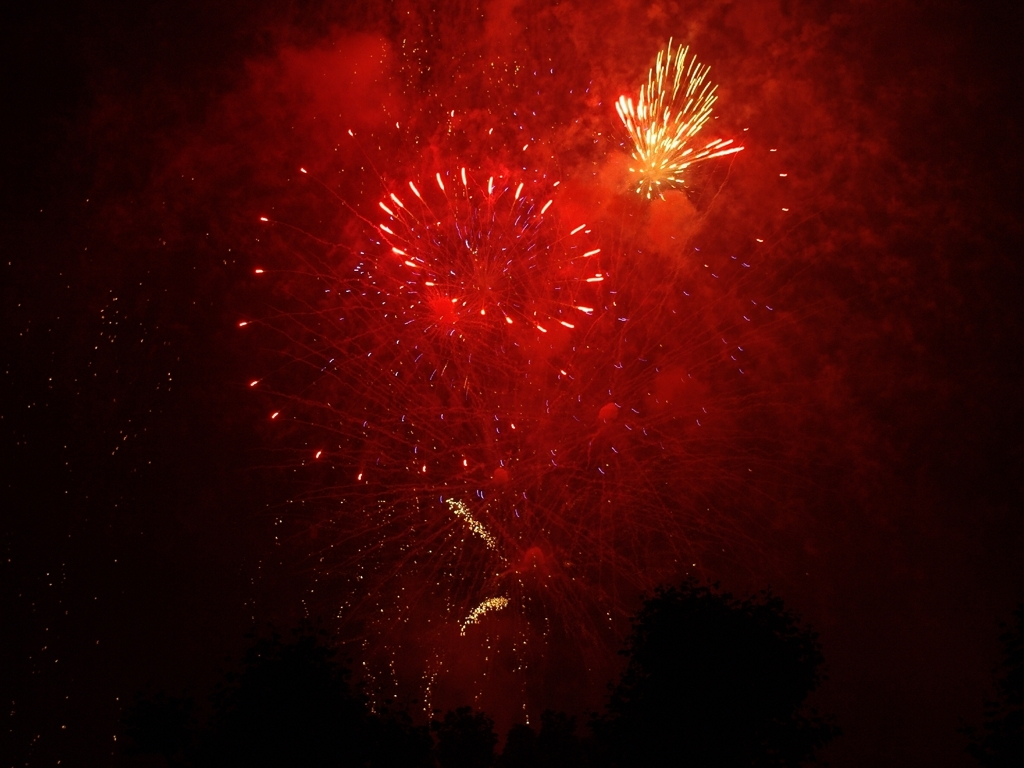What is the overall sharpness of this image? A. Average B. High C. Excellent D. Low Answer with the option's letter from the given choices directly. The overall sharpness of this image would best be classified as B. High. The individual sparks and bursts in the fireworks display are captured with clear edges and distinct shapes, indicating a high level of detail. The contrast between the fireworks and the dark sky also helps to accentuate the sharpness of the image's subjects. 